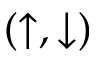Convert formula to latex. <formula><loc_0><loc_0><loc_500><loc_500>( \uparrow , \downarrow )</formula> 